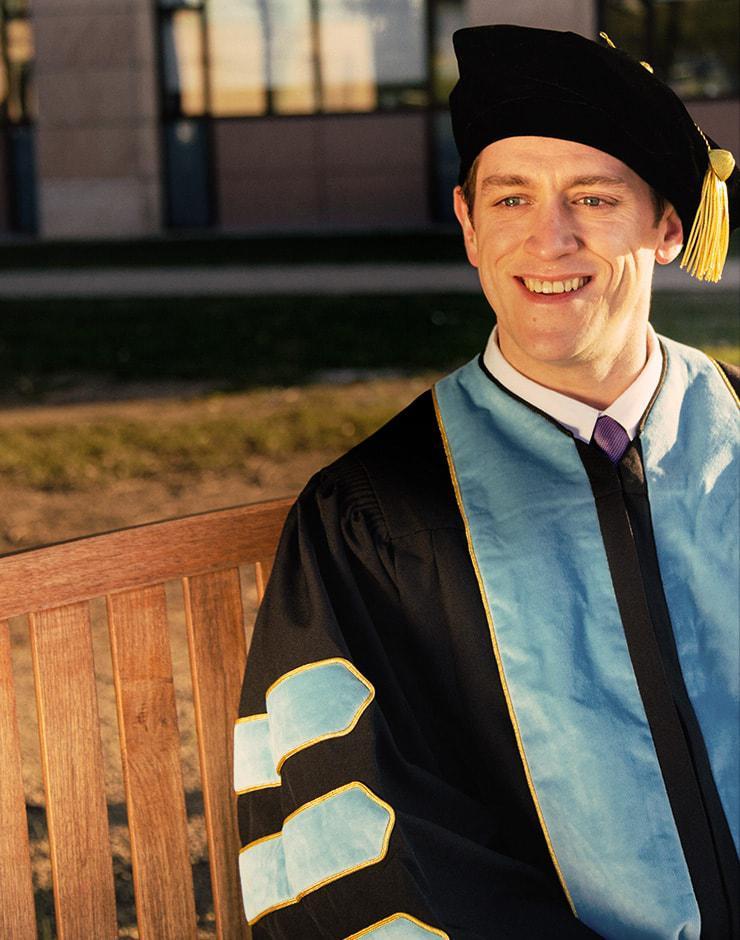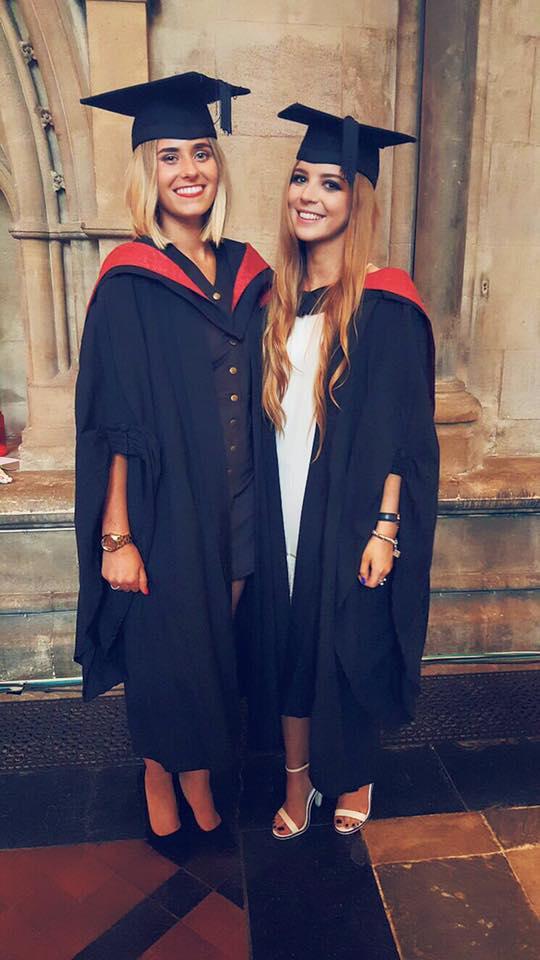The first image is the image on the left, the second image is the image on the right. Evaluate the accuracy of this statement regarding the images: "At least one image shows a mannequin modeling a graduation robe with three stripes on each sleeve.". Is it true? Answer yes or no. No. The first image is the image on the left, the second image is the image on the right. For the images shown, is this caption "The right image contains a mannequin wearing a graduation gown." true? Answer yes or no. No. 